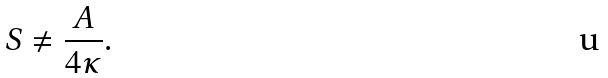Convert formula to latex. <formula><loc_0><loc_0><loc_500><loc_500>S \neq \frac { A } { 4 \kappa } .</formula> 